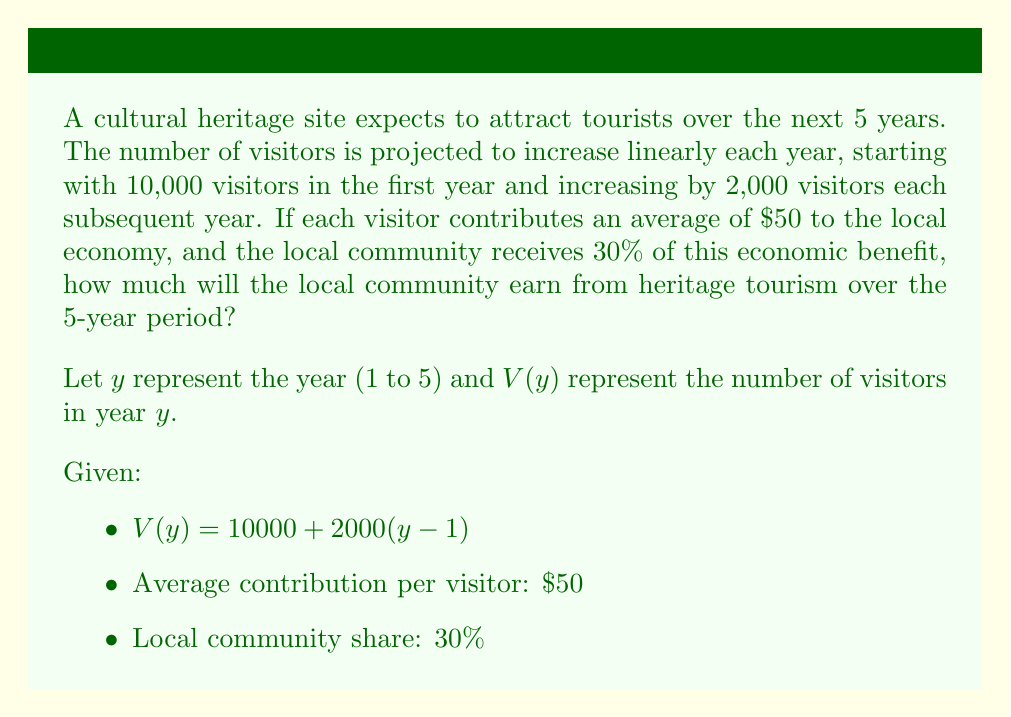Solve this math problem. 1. Express the number of visitors for each year:
   $V(1) = 10000 + 2000(1-1) = 10000$
   $V(2) = 10000 + 2000(2-1) = 12000$
   $V(3) = 10000 + 2000(3-1) = 14000$
   $V(4) = 10000 + 2000(4-1) = 16000$
   $V(5) = 10000 + 2000(5-1) = 18000$

2. Calculate total visitors over 5 years:
   $\text{Total Visitors} = 10000 + 12000 + 14000 + 16000 + 18000 = 70000$

3. Calculate total economic contribution:
   $\text{Total Contribution} = 70000 \times $50 = $3,500,000$

4. Calculate local community's share:
   $\text{Local Share} = $3,500,000 \times 30\% = $1,050,000$
Answer: $1,050,000 